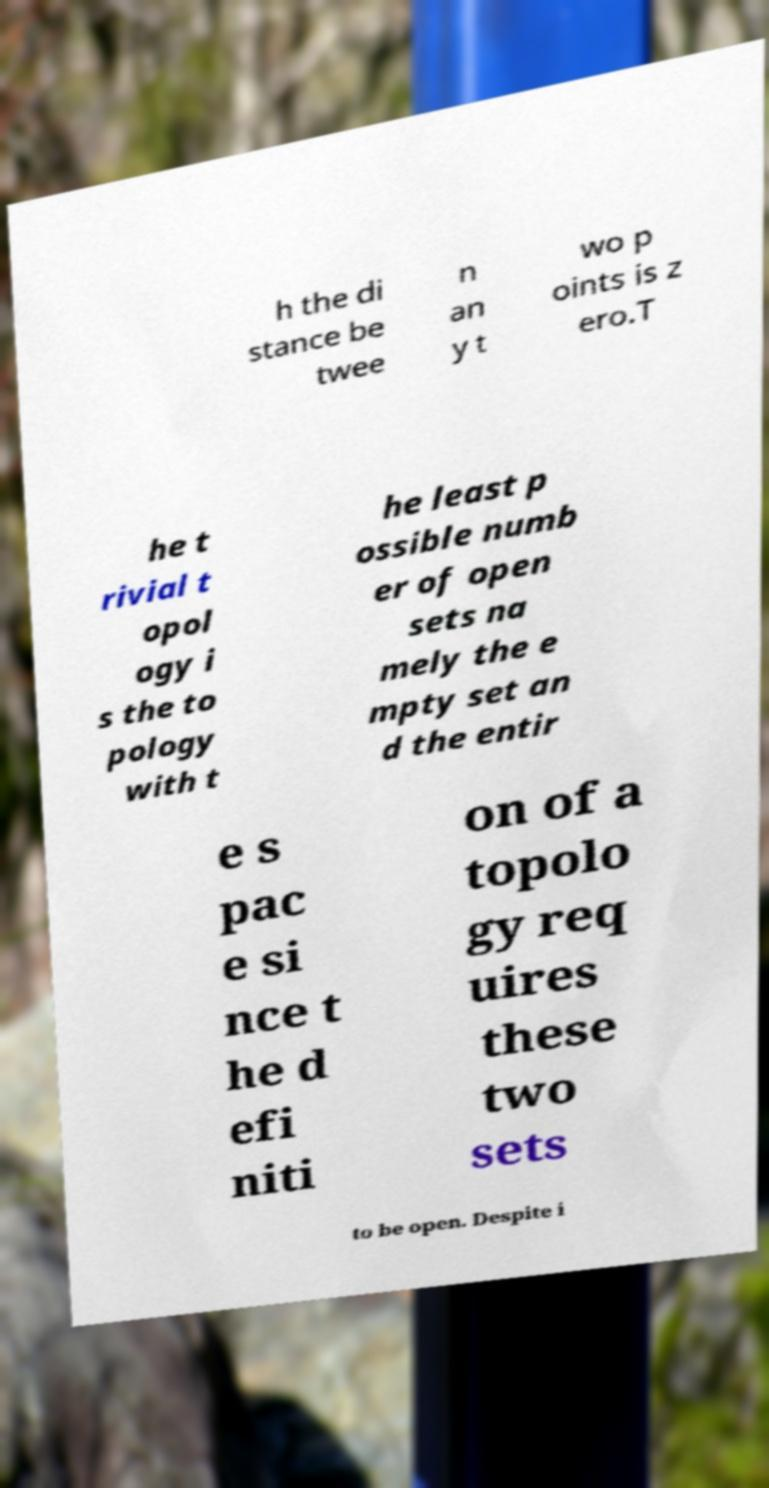What messages or text are displayed in this image? I need them in a readable, typed format. h the di stance be twee n an y t wo p oints is z ero.T he t rivial t opol ogy i s the to pology with t he least p ossible numb er of open sets na mely the e mpty set an d the entir e s pac e si nce t he d efi niti on of a topolo gy req uires these two sets to be open. Despite i 